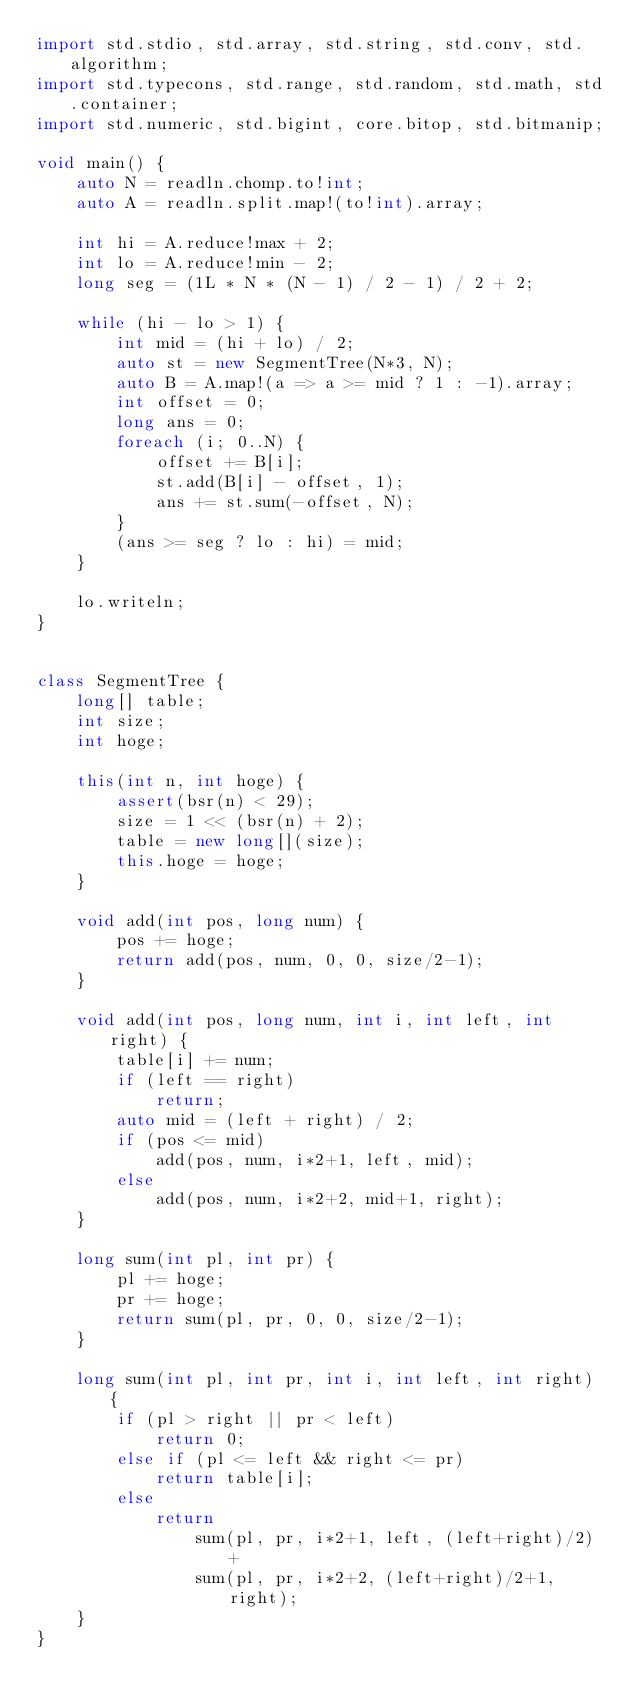Convert code to text. <code><loc_0><loc_0><loc_500><loc_500><_D_>import std.stdio, std.array, std.string, std.conv, std.algorithm;
import std.typecons, std.range, std.random, std.math, std.container;
import std.numeric, std.bigint, core.bitop, std.bitmanip;

void main() {
    auto N = readln.chomp.to!int;
    auto A = readln.split.map!(to!int).array;

    int hi = A.reduce!max + 2;
    int lo = A.reduce!min - 2;
    long seg = (1L * N * (N - 1) / 2 - 1) / 2 + 2;

    while (hi - lo > 1) {
        int mid = (hi + lo) / 2;
        auto st = new SegmentTree(N*3, N);
        auto B = A.map!(a => a >= mid ? 1 : -1).array;
        int offset = 0;
        long ans = 0;
        foreach (i; 0..N) {
            offset += B[i];
            st.add(B[i] - offset, 1);
            ans += st.sum(-offset, N);
        }
        (ans >= seg ? lo : hi) = mid;
    }

    lo.writeln;
}


class SegmentTree {
    long[] table;
    int size;
    int hoge;

    this(int n, int hoge) {
        assert(bsr(n) < 29);
        size = 1 << (bsr(n) + 2);
        table = new long[](size);
        this.hoge = hoge;
    }

    void add(int pos, long num) {
        pos += hoge;
        return add(pos, num, 0, 0, size/2-1);
    }

    void add(int pos, long num, int i, int left, int right) {
        table[i] += num;
        if (left == right)
            return;
        auto mid = (left + right) / 2;
        if (pos <= mid)
            add(pos, num, i*2+1, left, mid);
        else
            add(pos, num, i*2+2, mid+1, right);
    }

    long sum(int pl, int pr) {
        pl += hoge;
        pr += hoge;
        return sum(pl, pr, 0, 0, size/2-1);
    }

    long sum(int pl, int pr, int i, int left, int right) {
        if (pl > right || pr < left)
            return 0;
        else if (pl <= left && right <= pr)
            return table[i];
        else
            return
                sum(pl, pr, i*2+1, left, (left+right)/2) +
                sum(pl, pr, i*2+2, (left+right)/2+1, right);
    }
}
</code> 